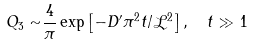<formula> <loc_0><loc_0><loc_500><loc_500>Q _ { 3 } \sim & \frac { 4 } { \pi } \exp \left [ - D ^ { \prime } \pi ^ { 2 } t / { \mathcal { L } } ^ { 2 } \right ] , \quad t \gg 1</formula> 